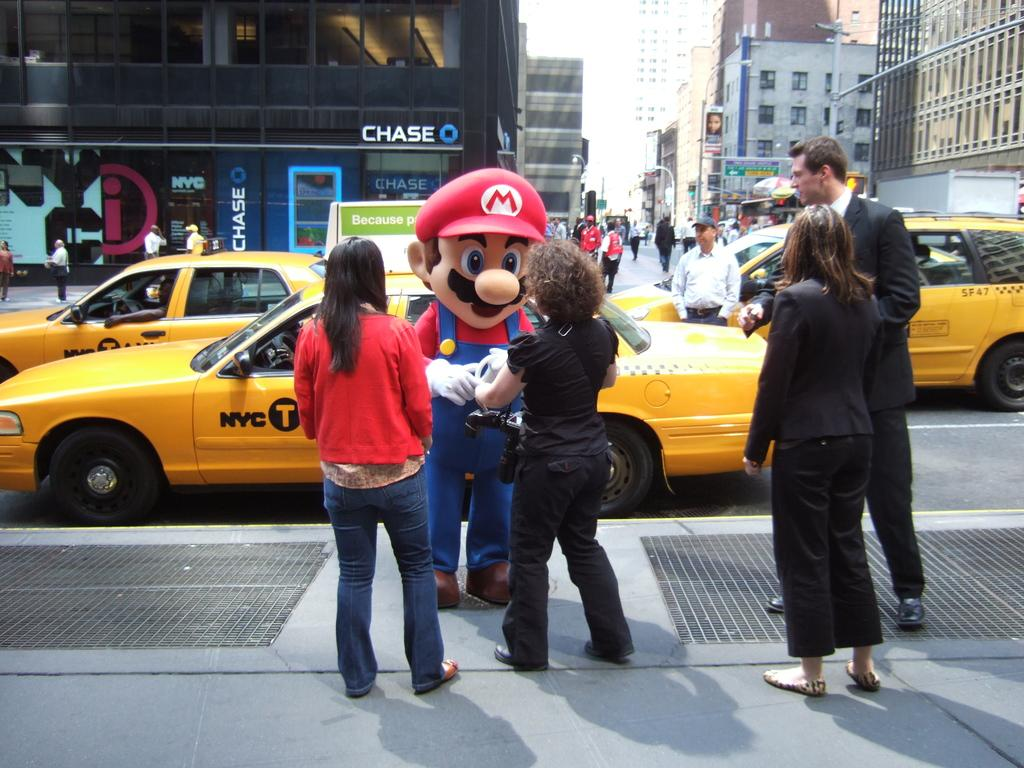<image>
Relay a brief, clear account of the picture shown. a Mario character that has an M on their hat 